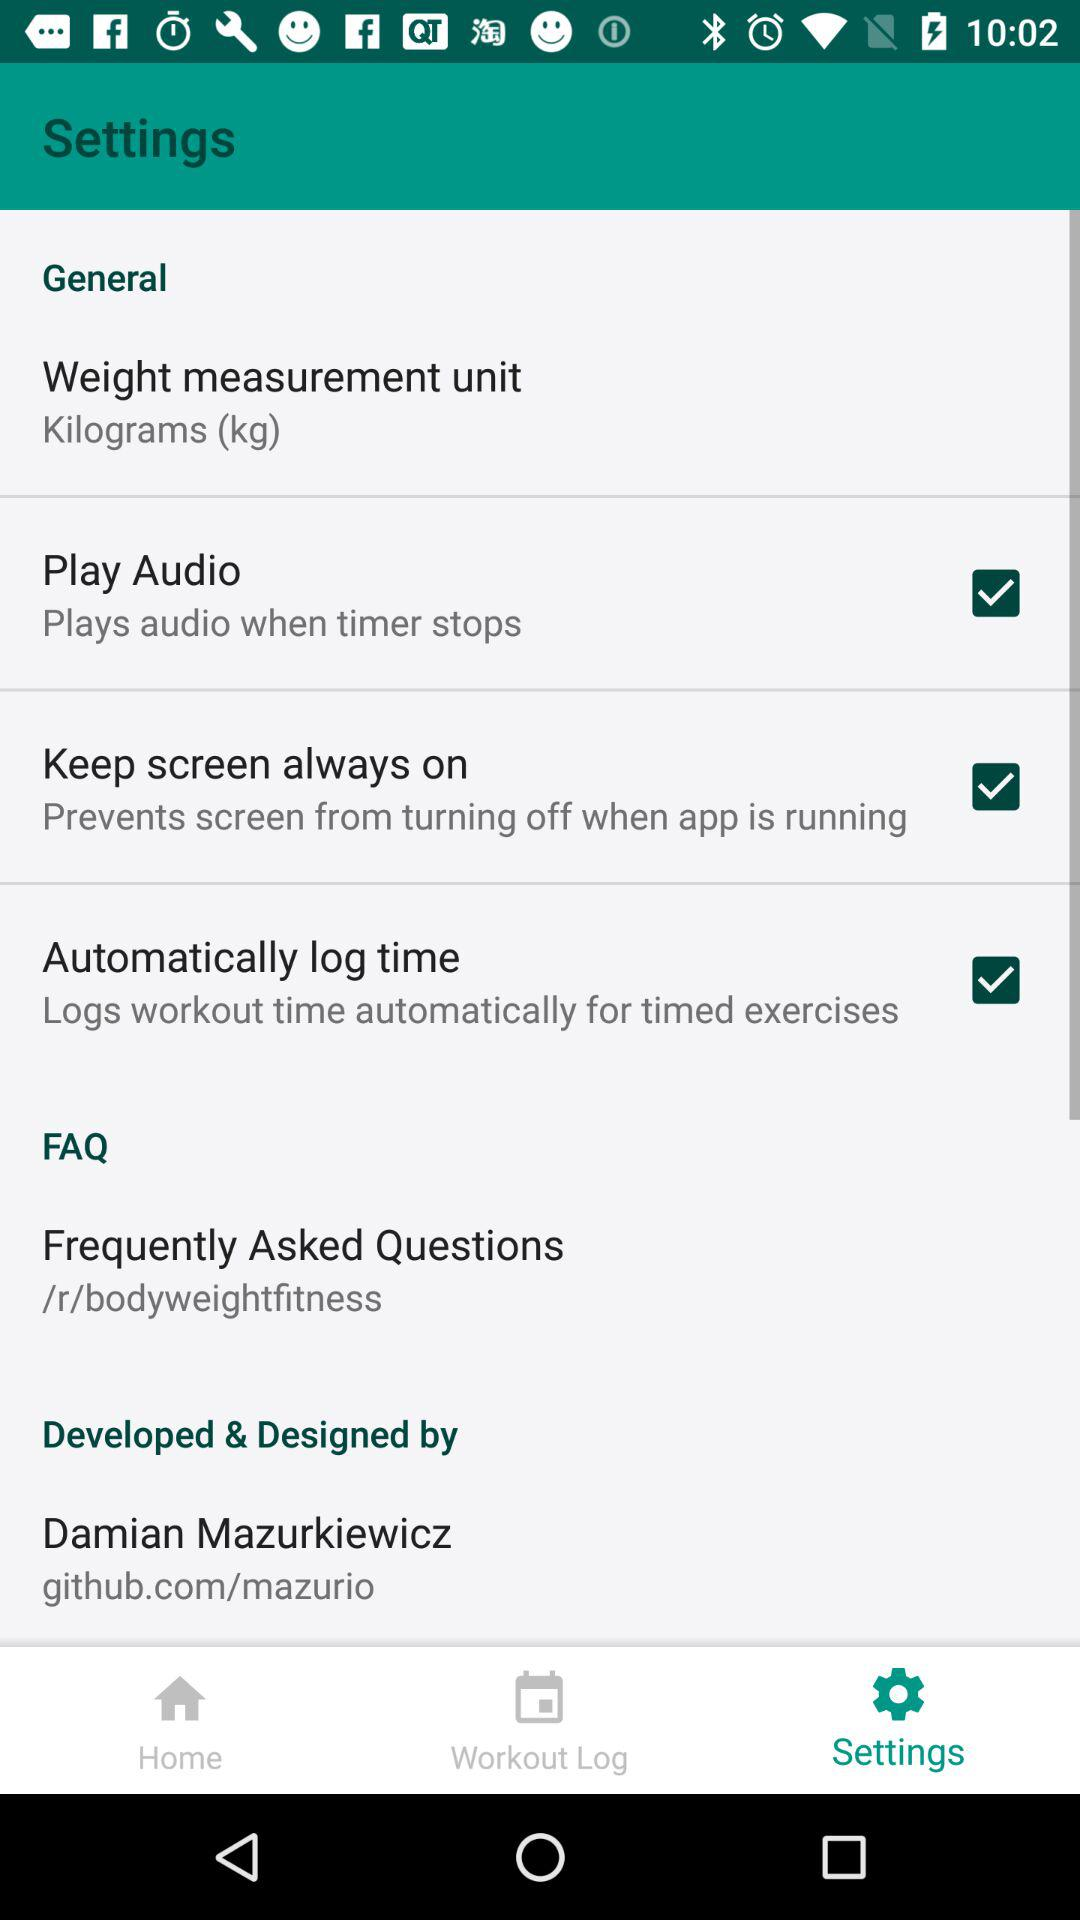What is the status of the "Play Audio" setting? The status of the "Play Audio" setting is "on". 